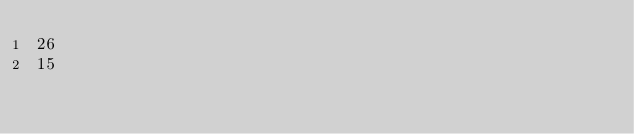<code> <loc_0><loc_0><loc_500><loc_500><_SQL_>26
15</code> 